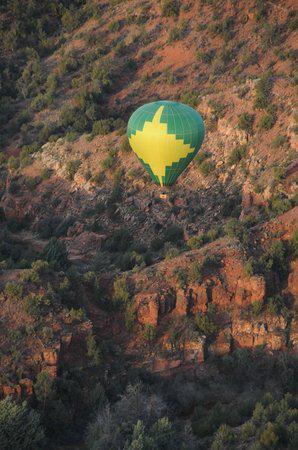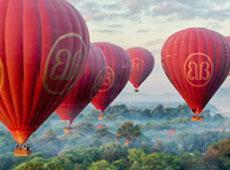The first image is the image on the left, the second image is the image on the right. Considering the images on both sides, is "There is at least one green and yellow balloon in the image on the left." valid? Answer yes or no. Yes. 